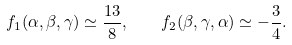<formula> <loc_0><loc_0><loc_500><loc_500>f _ { 1 } ( \alpha , \beta , \gamma ) \simeq \frac { 1 3 } { 8 } , \quad f _ { 2 } ( \beta , \gamma , \alpha ) \simeq - \frac { 3 } { 4 } .</formula> 